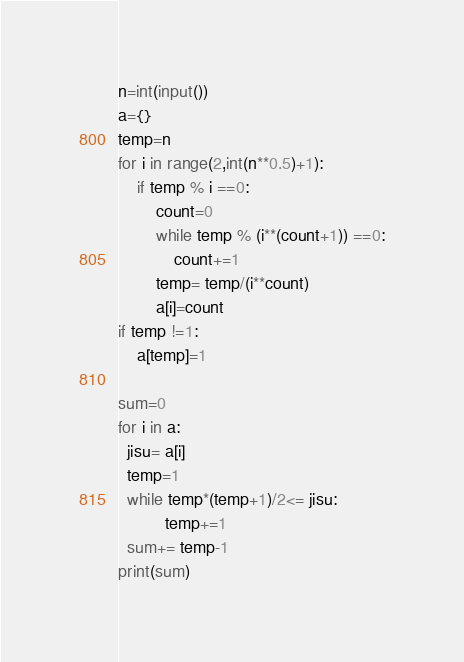Convert code to text. <code><loc_0><loc_0><loc_500><loc_500><_Python_>n=int(input())
a={}
temp=n
for i in range(2,int(n**0.5)+1):
    if temp % i ==0:
        count=0
        while temp % (i**(count+1)) ==0:
            count+=1
        temp= temp/(i**count)
        a[i]=count
if temp !=1:
    a[temp]=1

sum=0
for i in a:
  jisu= a[i]
  temp=1
  while temp*(temp+1)/2<= jisu:
          temp+=1
  sum+= temp-1
print(sum)</code> 